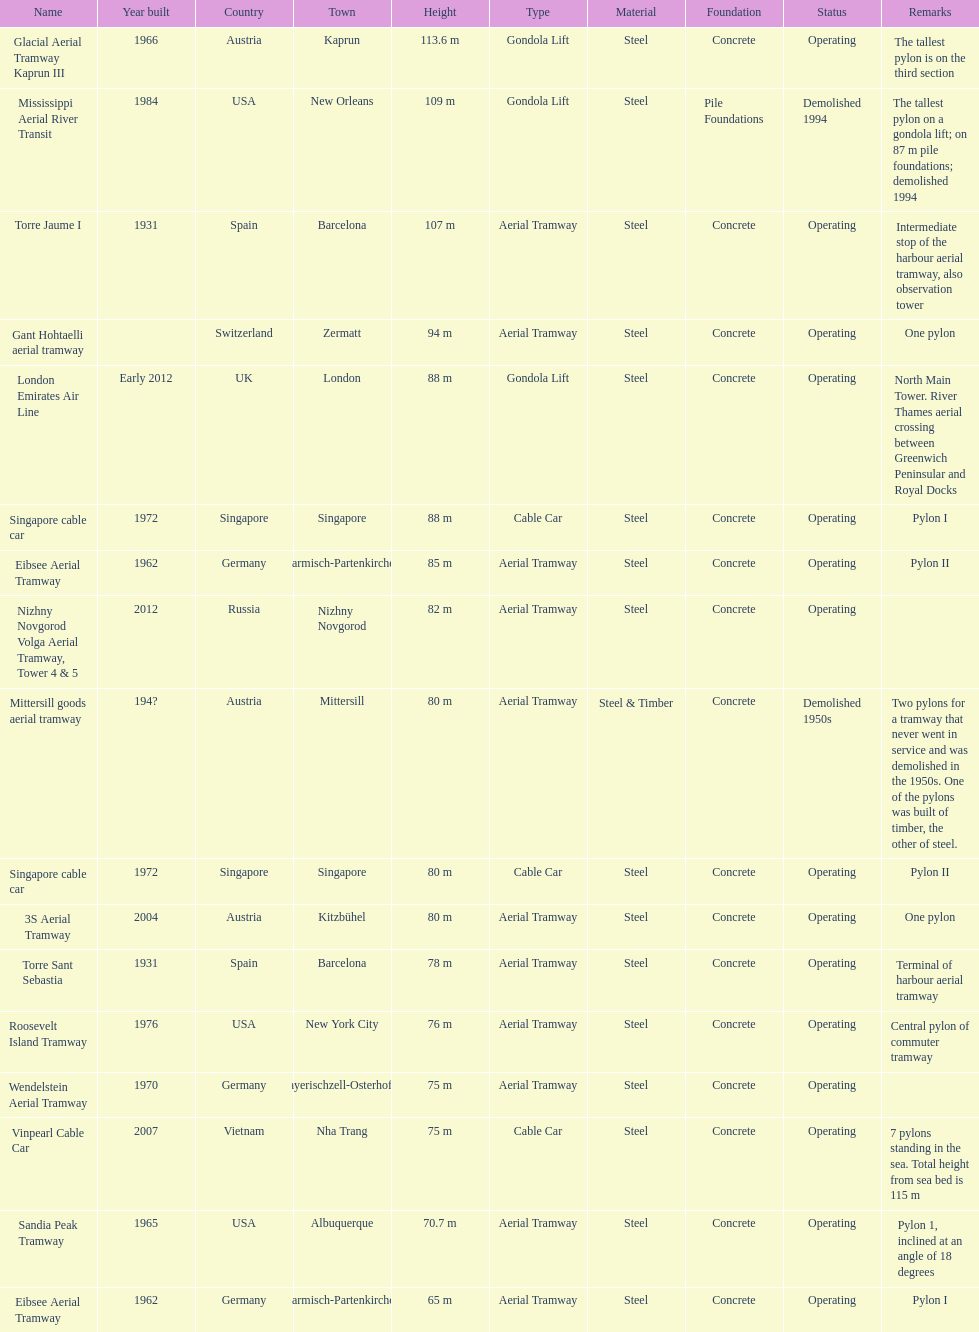How many pylons are at least 80 meters tall? 11. 